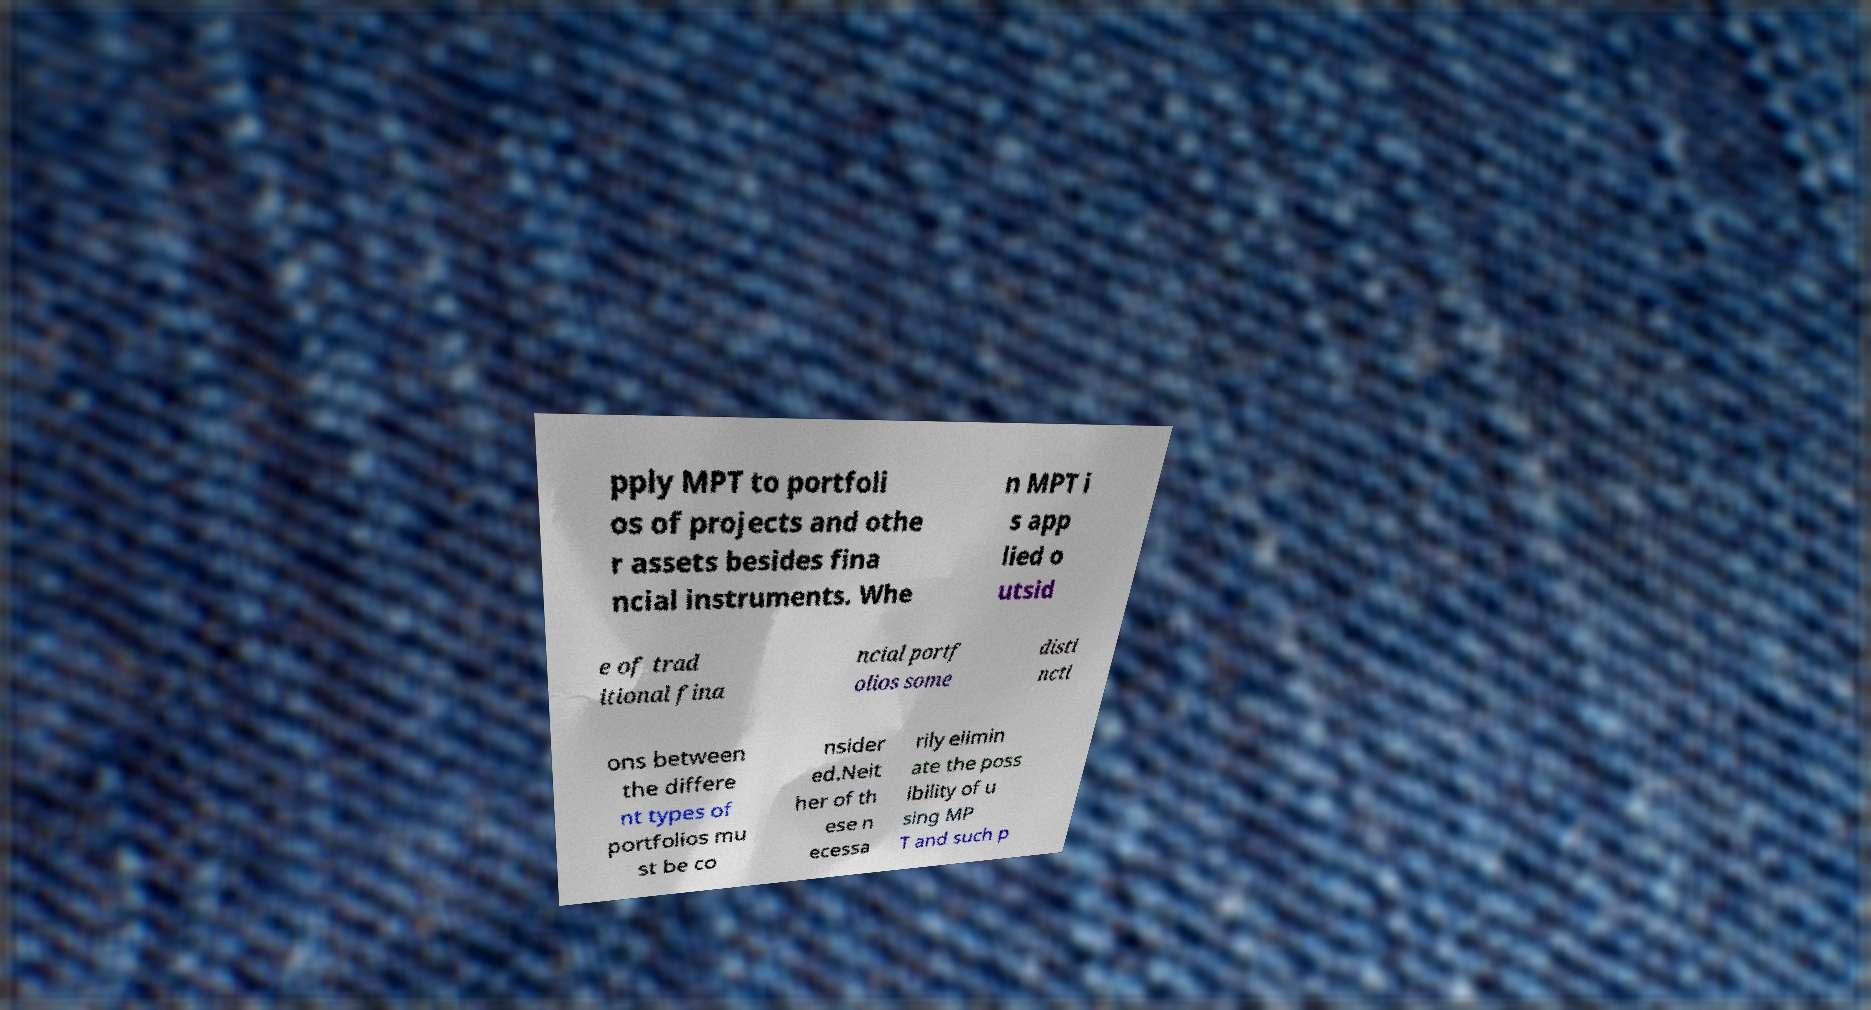Please read and relay the text visible in this image. What does it say? pply MPT to portfoli os of projects and othe r assets besides fina ncial instruments. Whe n MPT i s app lied o utsid e of trad itional fina ncial portf olios some disti ncti ons between the differe nt types of portfolios mu st be co nsider ed.Neit her of th ese n ecessa rily elimin ate the poss ibility of u sing MP T and such p 